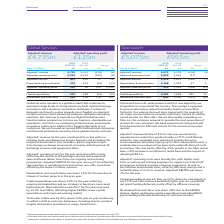According to Bt Group Plc's financial document, What is the  Adjusted a revenue for 2019? According to the financial document, 5,075 (in millions). The relevant text states: "Adjusted a revenue 5,075 5,278 (203) (4)..." Also, What was the reason for decrease in Adjusteda revenue decline? driven by regulated price reductions predominantly on FTTC and Ethernet products, non-regulated price reductions (mainly driven by communications providers signing up for fibre volume discounts), a small decline in our physical line base and a reclassification of costs to revenue. The document states: "Adjusted a revenue decline of 4% for the year was driven by regulated price reductions predominantly on FTTC and Ethernet products, non-regulated pric..." Also, What was  Capital expenditure for 2018 and 2019 respectively? The document shows two values: 1,699 and 2,081 (in millions). From the document: "Capital expenditure 2,081 1,699 382 22 Capital expenditure 2,081 1,699 382 22..." Also, can you calculate: What was the average Adjusted EBITDA for 2018 and 2019? To answer this question, I need to perform calculations using the financial data. The calculation is: (2,423 + 2,615) / 2, which equals 2519 (in millions). This is based on the information: "Adjusted a EBITDA 2,423 2,615 (192) (7) Adjusted a EBITDA 2,423 2,615 (192) (7)..." The key data points involved are: 2,423, 2,615. Also, can you calculate: What  was the EBITDA margin in 2019? Based on the calculation: 2,423 / 5,075, the result is 0.48. This is based on the information: "Adjusted a EBITDA 2,423 2,615 (192) (7) Adjusted a revenue 5,075 5,278 (203) (4)..." The key data points involved are: 2,423, 5,075. Also, can you calculate: What is the average Adjusteda operating costs for 2018 and 2019? To answer this question, I need to perform calculations using the financial data. The calculation is: (2,652 + 2,663) / 2, which equals 2657.5 (in millions). This is based on the information: "Adjusted a operating costs 2,652 2,663 (11) – Adjusted a operating costs 2,652 2,663 (11) –..." The key data points involved are: 2,652, 2,663. 